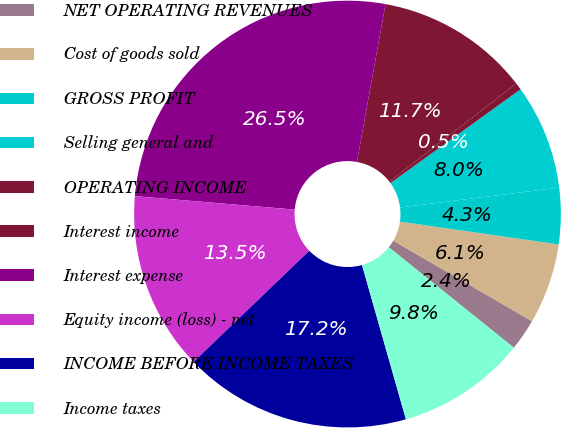Convert chart. <chart><loc_0><loc_0><loc_500><loc_500><pie_chart><fcel>NET OPERATING REVENUES<fcel>Cost of goods sold<fcel>GROSS PROFIT<fcel>Selling general and<fcel>OPERATING INCOME<fcel>Interest income<fcel>Interest expense<fcel>Equity income (loss) - net<fcel>INCOME BEFORE INCOME TAXES<fcel>Income taxes<nl><fcel>2.4%<fcel>6.1%<fcel>4.25%<fcel>7.96%<fcel>0.54%<fcel>11.67%<fcel>26.51%<fcel>13.52%<fcel>17.23%<fcel>9.81%<nl></chart> 